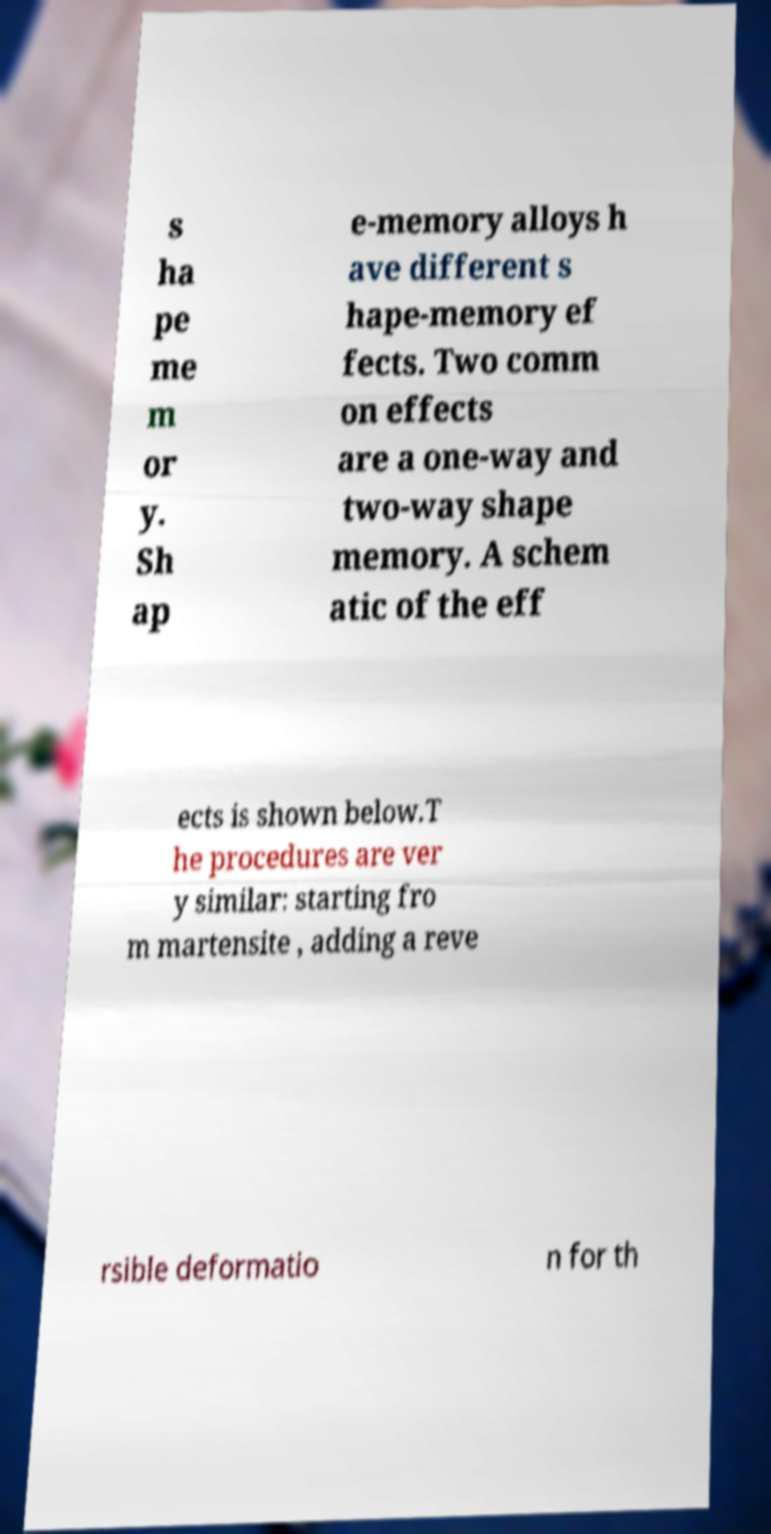What messages or text are displayed in this image? I need them in a readable, typed format. s ha pe me m or y. Sh ap e-memory alloys h ave different s hape-memory ef fects. Two comm on effects are a one-way and two-way shape memory. A schem atic of the eff ects is shown below.T he procedures are ver y similar: starting fro m martensite , adding a reve rsible deformatio n for th 